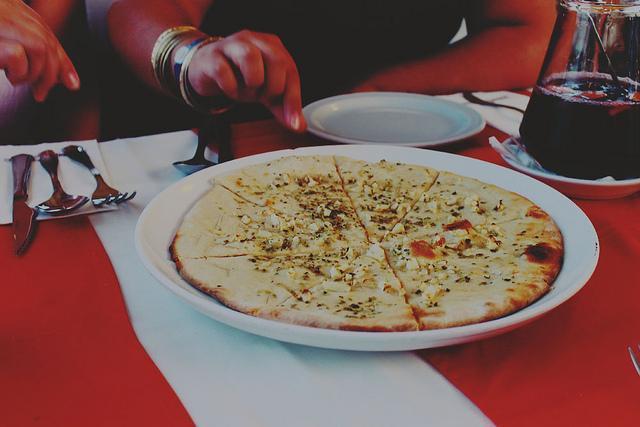What can one of the shiny silver things do?
Indicate the correct response by choosing from the four available options to answer the question.
Options: Cut, generate electricity, drive, compute. Cut. What Leavening was used in this dish?
Select the correct answer and articulate reasoning with the following format: 'Answer: answer
Rationale: rationale.'
Options: Yeast, none, rye, sour kraut. Answer: yeast.
Rationale: Yeast is used in dough. 